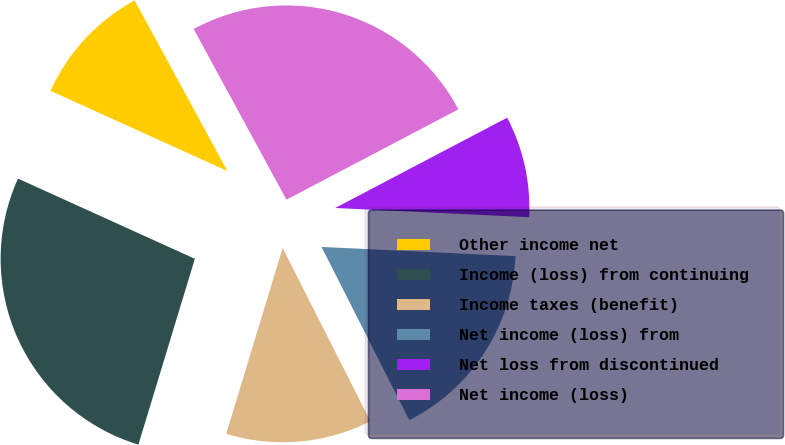<chart> <loc_0><loc_0><loc_500><loc_500><pie_chart><fcel>Other income net<fcel>Income (loss) from continuing<fcel>Income taxes (benefit)<fcel>Net income (loss) from<fcel>Net loss from discontinued<fcel>Net income (loss)<nl><fcel>10.3%<fcel>27.08%<fcel>12.16%<fcel>16.78%<fcel>8.45%<fcel>25.23%<nl></chart> 